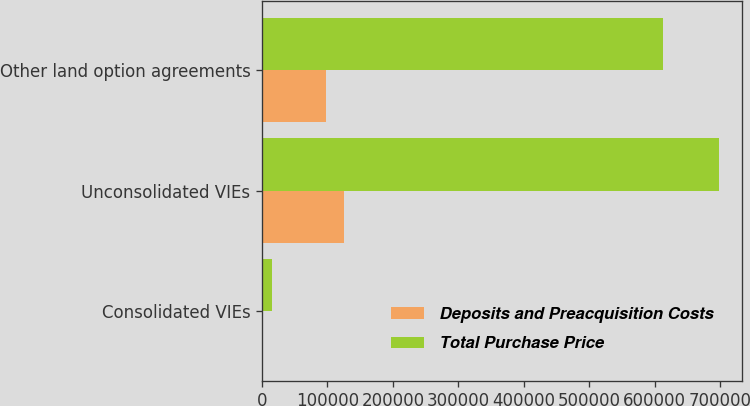<chart> <loc_0><loc_0><loc_500><loc_500><stacked_bar_chart><ecel><fcel>Consolidated VIEs<fcel>Unconsolidated VIEs<fcel>Other land option agreements<nl><fcel>Deposits and Preacquisition Costs<fcel>1923<fcel>125307<fcel>98062<nl><fcel>Total Purchase Price<fcel>15841<fcel>698418<fcel>612900<nl></chart> 